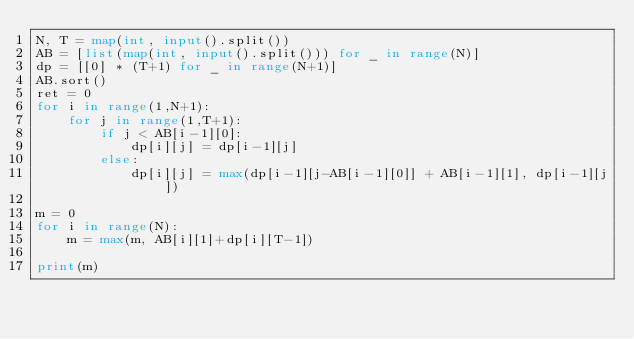Convert code to text. <code><loc_0><loc_0><loc_500><loc_500><_Python_>N, T = map(int, input().split())
AB = [list(map(int, input().split())) for _ in range(N)]
dp = [[0] * (T+1) for _ in range(N+1)]
AB.sort()
ret = 0
for i in range(1,N+1):
    for j in range(1,T+1):
        if j < AB[i-1][0]:
            dp[i][j] = dp[i-1][j]
        else:
            dp[i][j] = max(dp[i-1][j-AB[i-1][0]] + AB[i-1][1], dp[i-1][j])

m = 0
for i in range(N):
    m = max(m, AB[i][1]+dp[i][T-1])

print(m)
</code> 